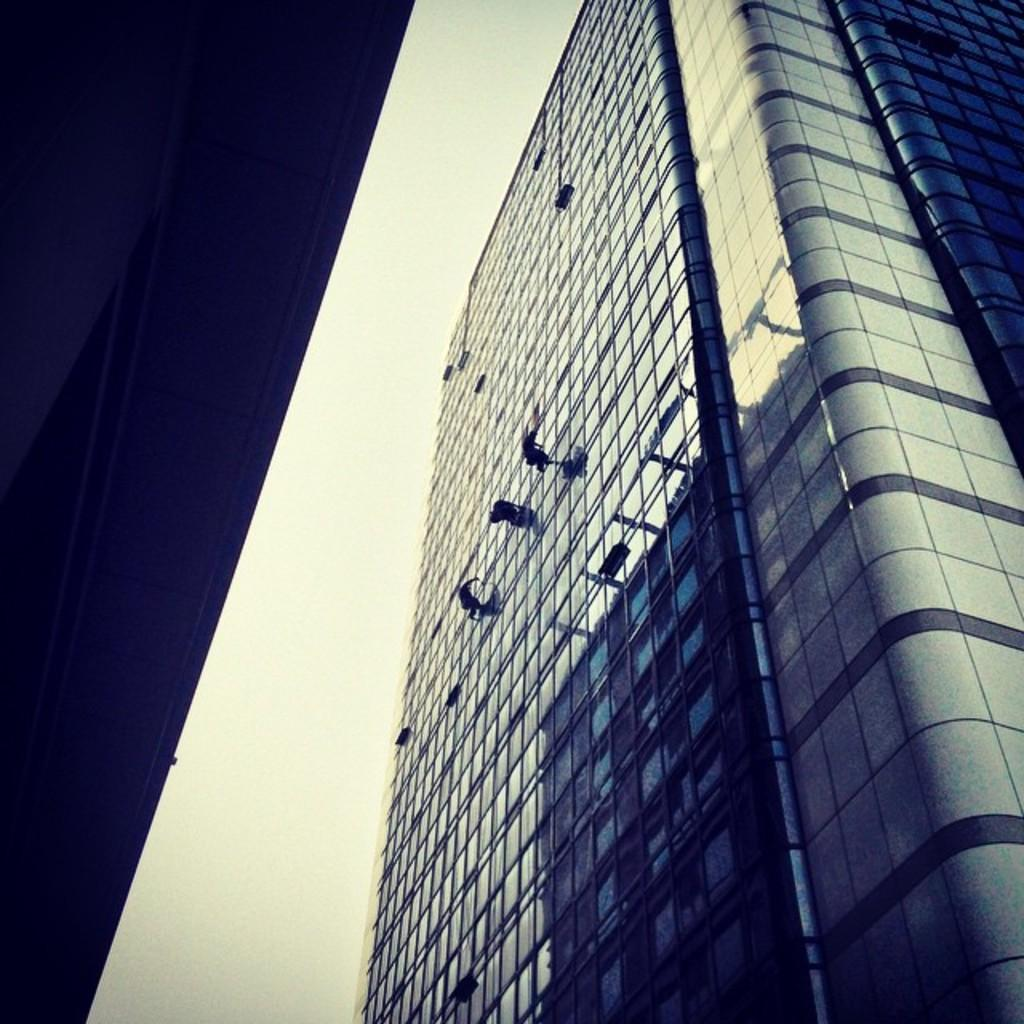What is located on the left side of the image? There are buildings on the left side of the image. What is located on the right side of the image? There are buildings on the right side of the image. What can be seen in the background of the image? The sky is visible in the background of the image. How many pairs of shoes are visible in the image? There are no shoes present in the image. What type of office can be seen in the image? There is no office present in the image. 